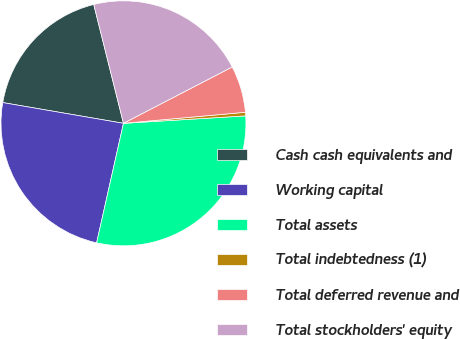Convert chart to OTSL. <chart><loc_0><loc_0><loc_500><loc_500><pie_chart><fcel>Cash cash equivalents and<fcel>Working capital<fcel>Total assets<fcel>Total indebtedness (1)<fcel>Total deferred revenue and<fcel>Total stockholders' equity<nl><fcel>18.39%<fcel>24.19%<fcel>29.48%<fcel>0.47%<fcel>6.17%<fcel>21.29%<nl></chart> 